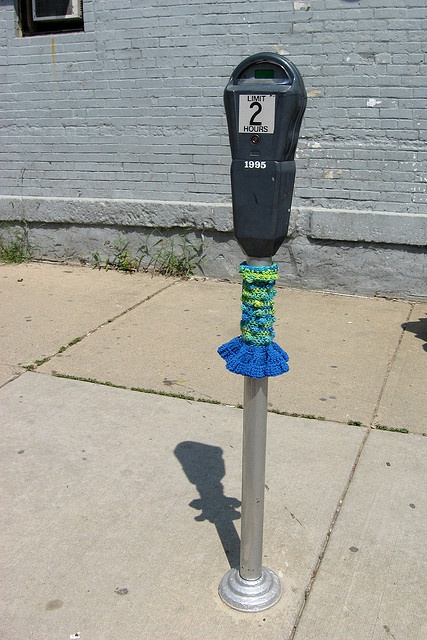Describe the objects in this image and their specific colors. I can see a parking meter in purple, black, darkgray, and gray tones in this image. 